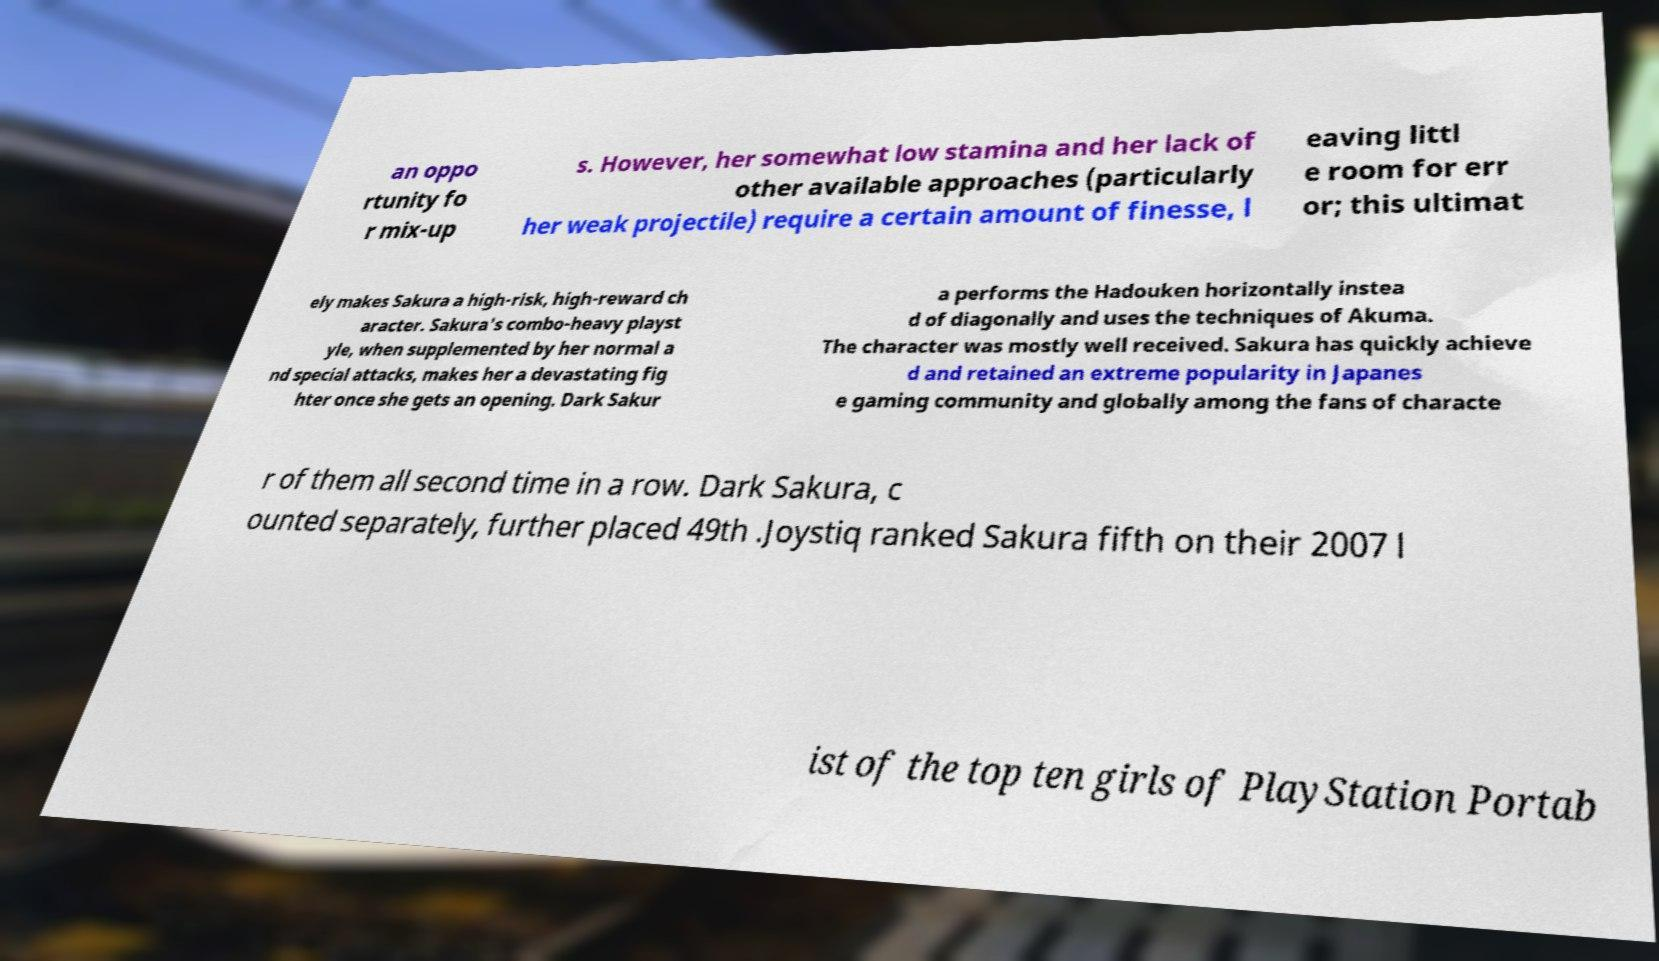Can you read and provide the text displayed in the image?This photo seems to have some interesting text. Can you extract and type it out for me? an oppo rtunity fo r mix-up s. However, her somewhat low stamina and her lack of other available approaches (particularly her weak projectile) require a certain amount of finesse, l eaving littl e room for err or; this ultimat ely makes Sakura a high-risk, high-reward ch aracter. Sakura's combo-heavy playst yle, when supplemented by her normal a nd special attacks, makes her a devastating fig hter once she gets an opening. Dark Sakur a performs the Hadouken horizontally instea d of diagonally and uses the techniques of Akuma. The character was mostly well received. Sakura has quickly achieve d and retained an extreme popularity in Japanes e gaming community and globally among the fans of characte r of them all second time in a row. Dark Sakura, c ounted separately, further placed 49th .Joystiq ranked Sakura fifth on their 2007 l ist of the top ten girls of PlayStation Portab 